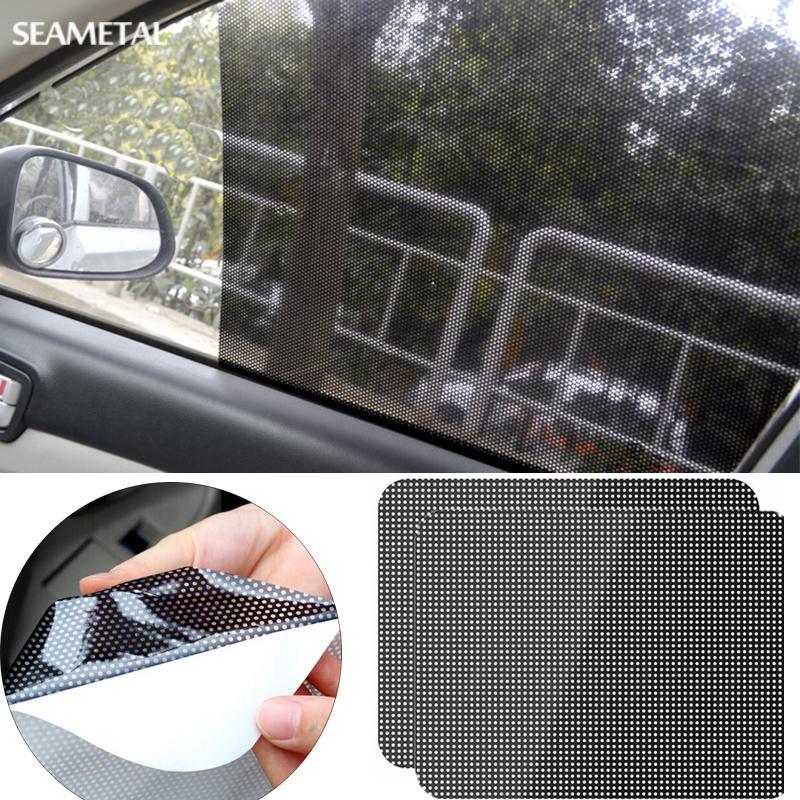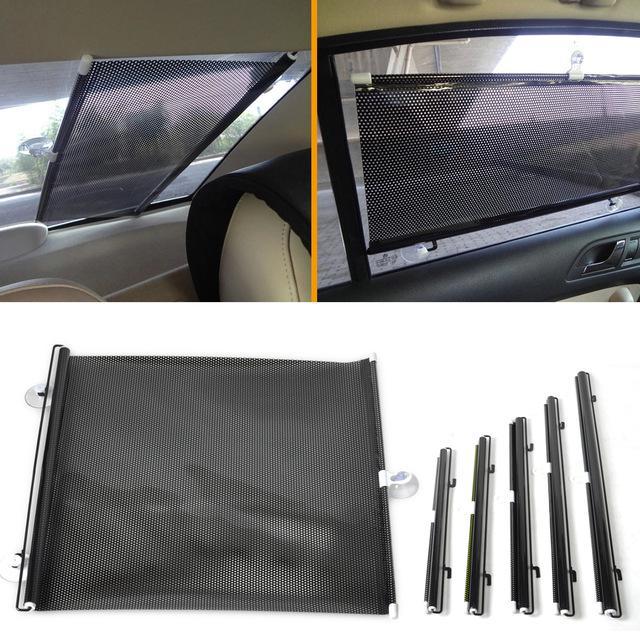The first image is the image on the left, the second image is the image on the right. Analyze the images presented: Is the assertion "There are a pair of hands with the right hand splayed out and the left balled up." valid? Answer yes or no. No. 